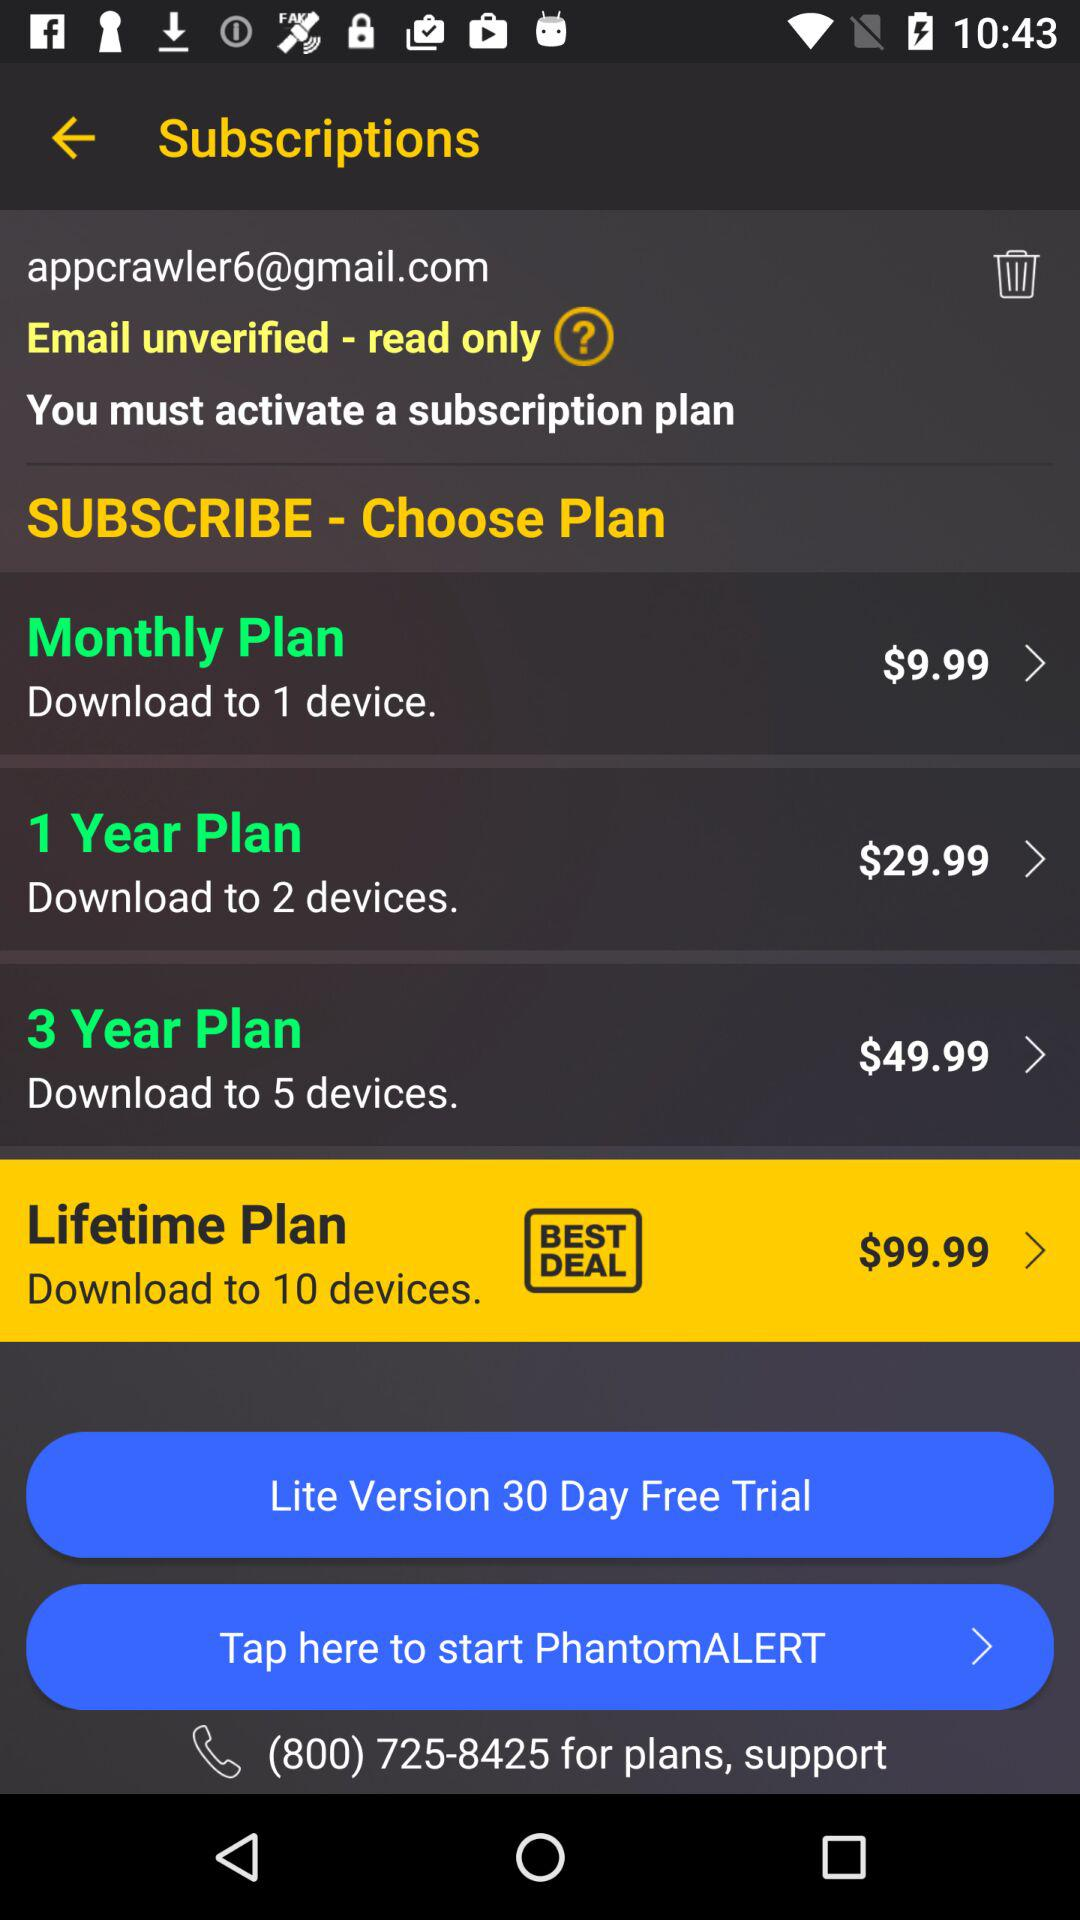What is the price of the "1 Year Plan"? The price of the "1 Year Plan" is $29.99. 